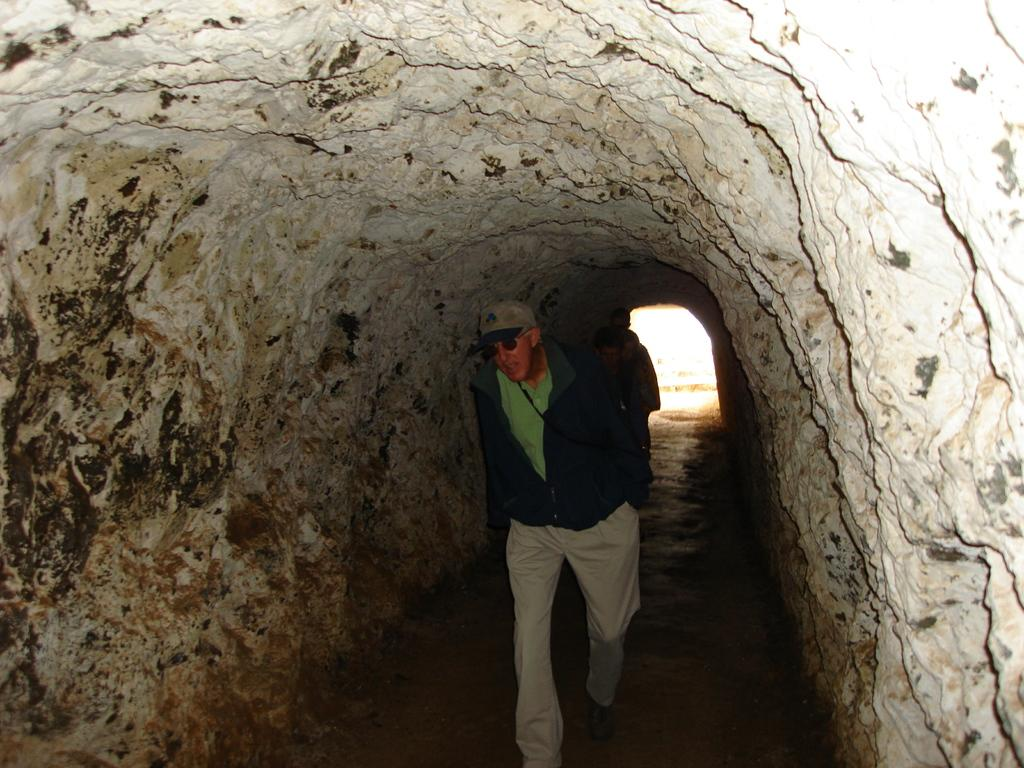How many people are present in the image? There are three people in the image. What type of structure can be seen in the image? There is a tunnel in the image. What riddle does the worm ask the people in the image? There is no worm present in the image, and therefore no such riddle can be observed. What discovery do the people make while inside the tunnel in the image? The facts provided do not mention any discovery made by the people in the image. 